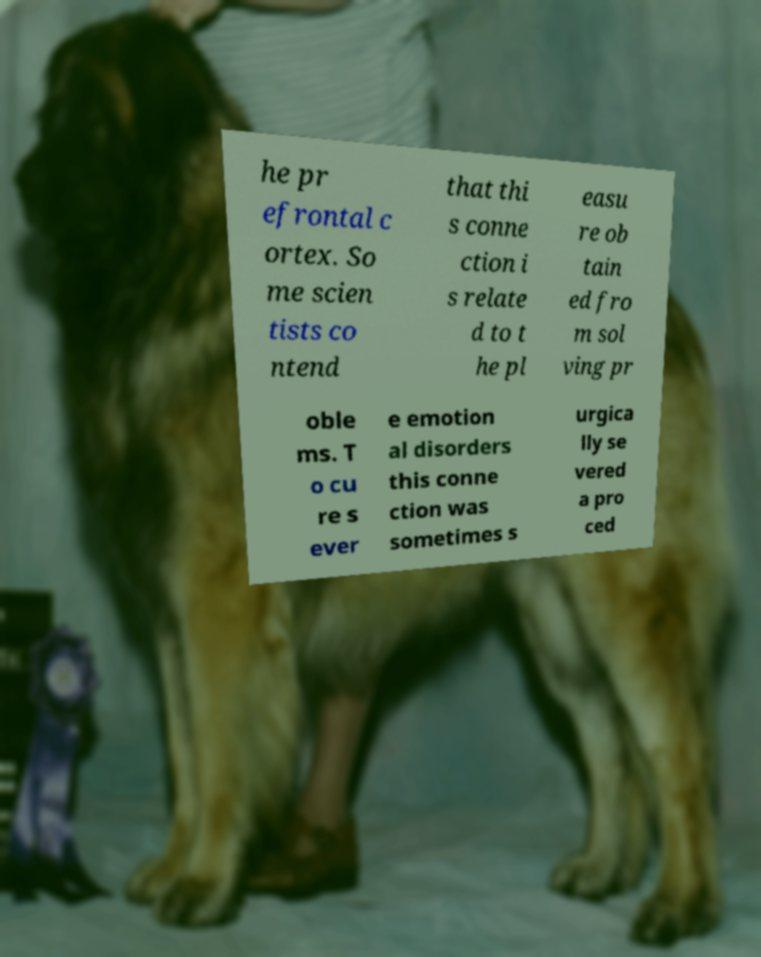I need the written content from this picture converted into text. Can you do that? he pr efrontal c ortex. So me scien tists co ntend that thi s conne ction i s relate d to t he pl easu re ob tain ed fro m sol ving pr oble ms. T o cu re s ever e emotion al disorders this conne ction was sometimes s urgica lly se vered a pro ced 